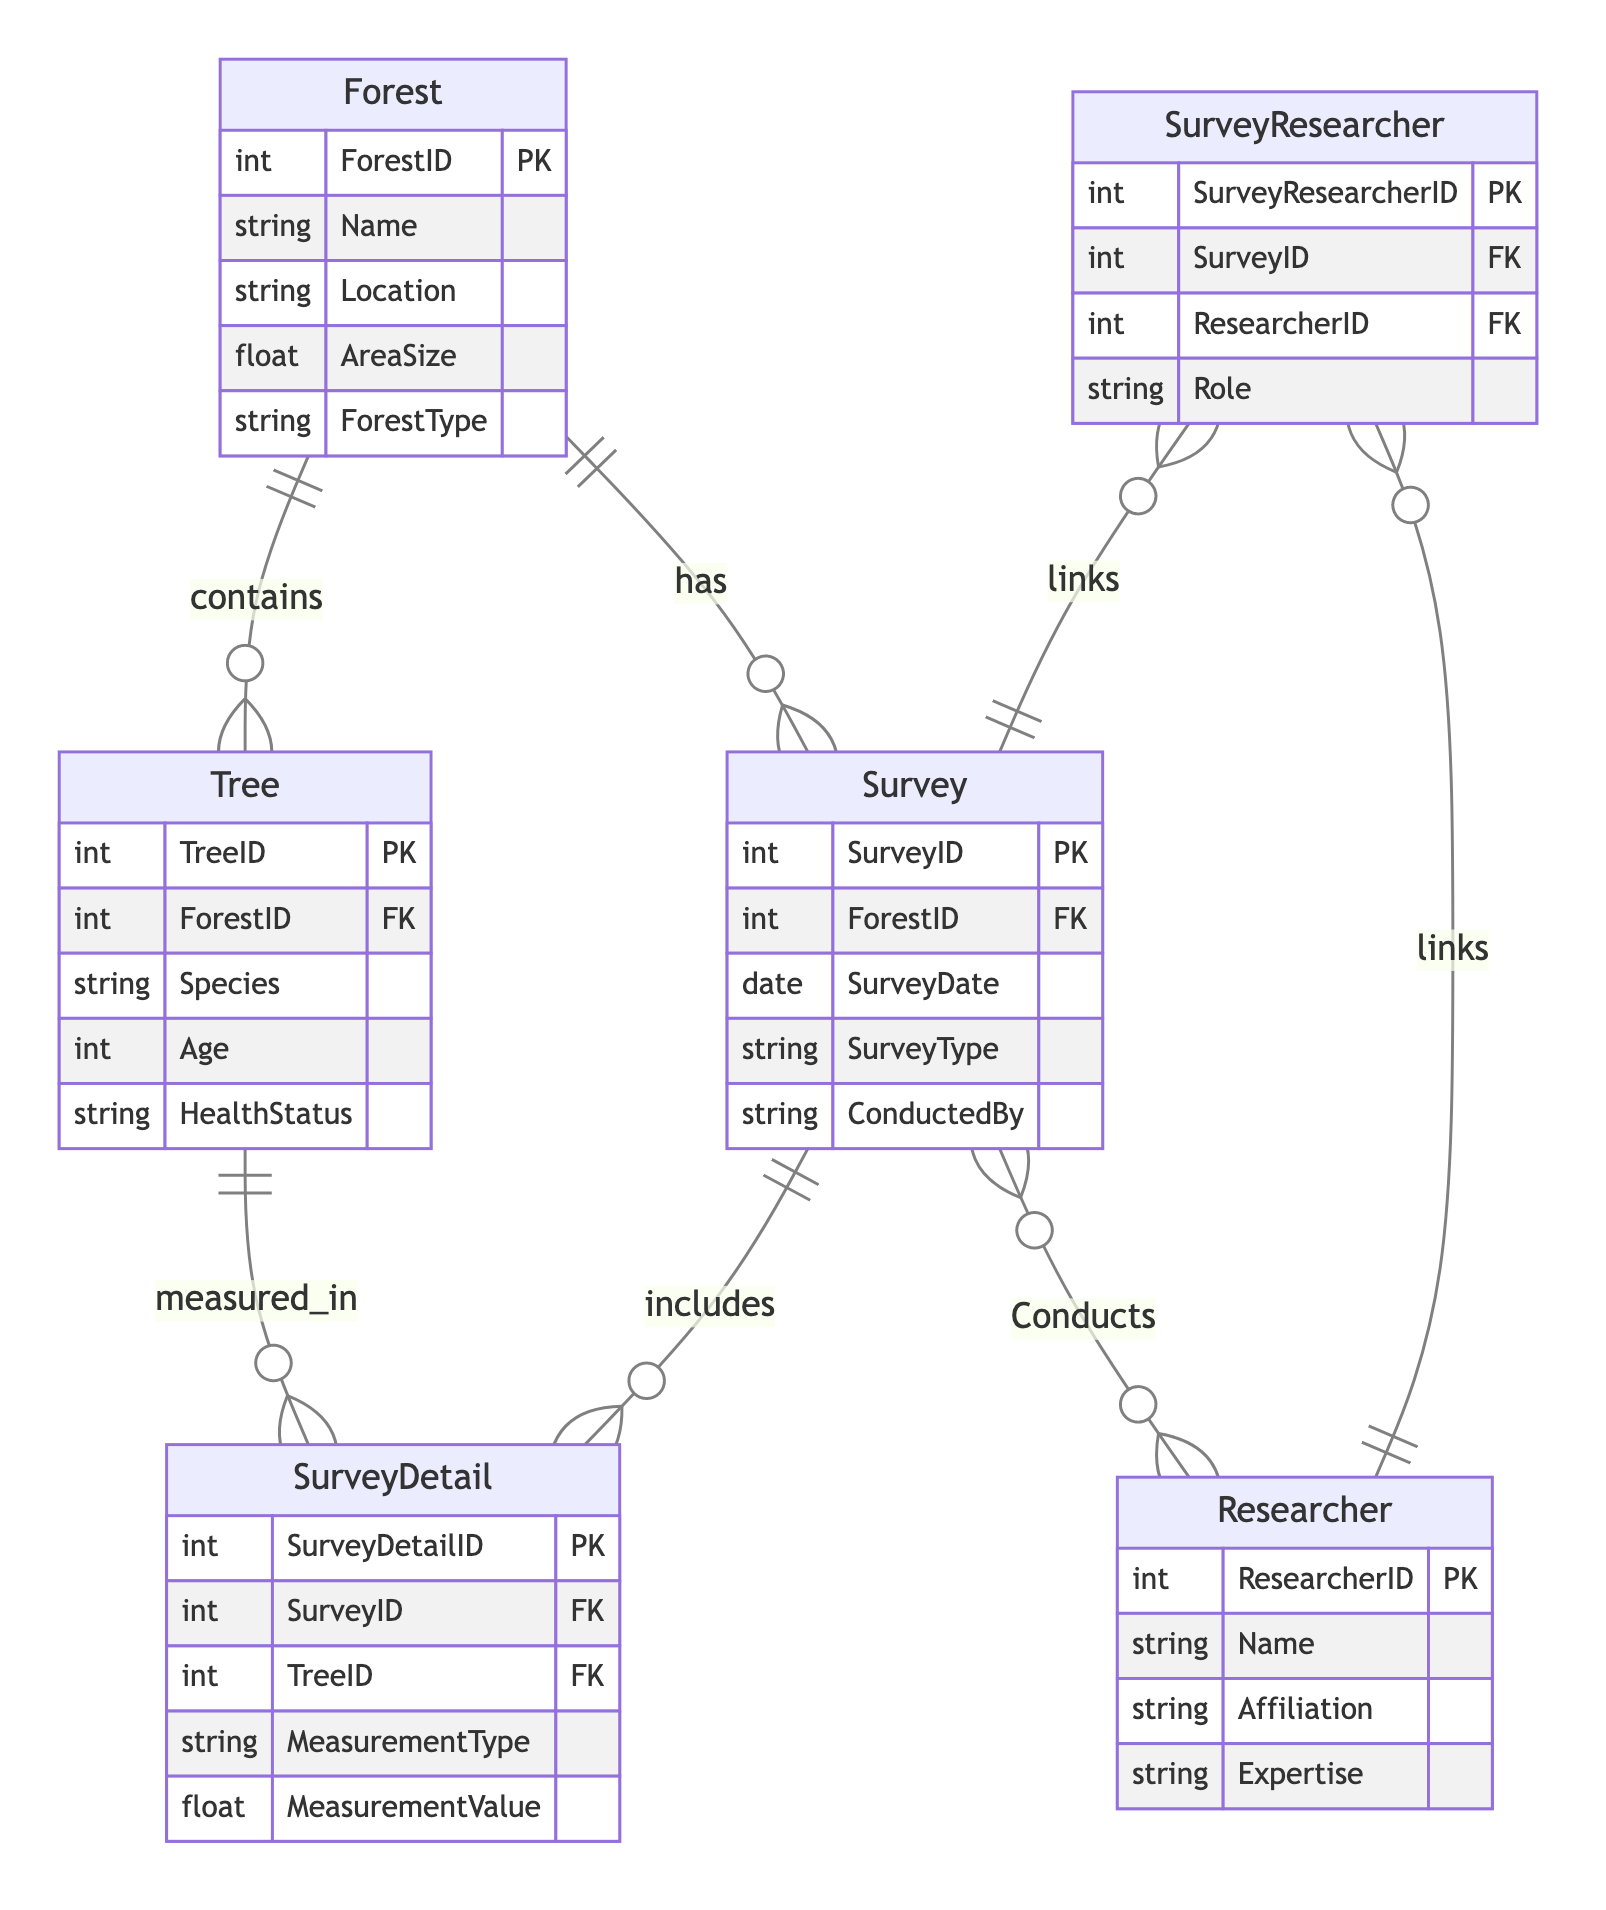What is the primary key of the Forest entity? The primary key for the Forest entity is clearly indicated in the diagram and is labeled as ForestID. It is a unique identifier for each forest in the system.
Answer: ForestID How many attributes does the Tree entity have? By counting the listed attributes in the Tree entity within the diagram, we see there are five attributes: TreeID, ForestID, Species, Age, and HealthStatus. Thus, the total count is five.
Answer: 5 What relationship exists between Survey and Researcher? The relationship between Survey and Researcher is indicated as a many-to-many relationship called "Conducts". This means multiple researchers can conduct multiple surveys.
Answer: Conducts Which entity contains the attribute "AreaSize"? The AreaSize attribute is specified in the Forest entity. This attribute represents the size of the forest in a numerical format.
Answer: Forest How many foreign keys are present in the SurveyDetail entity? The SurveyDetail entity has two foreign keys. These are SurveyID, which references the Survey entity, and TreeID, which references the Tree entity.
Answer: 2 What is the role of the SurveyResearcher table? The SurveyResearcher table serves as an intermediate table that links the Survey and Researcher entities, helping to define their many-to-many relationship. It records the associations along with roles of researchers.
Answer: links Which entity is related to a tree having a health status? The Tree entity is directly associated with a health status as one of its attributes, allowing the system to track the health condition of individual trees.
Answer: Tree What is the primary key of the Survey entity? The primary key for the Survey entity is identified as SurveyID, acting as a unique identifier for each survey conducted in the system.
Answer: SurveyID How many entities are there in total in this diagram? By counting the listed entities within the diagram, we identify that there are six entities: Forest, Tree, Survey, Researcher, SurveyDetail, and SurveyResearcher. Thus, the total is six.
Answer: 6 